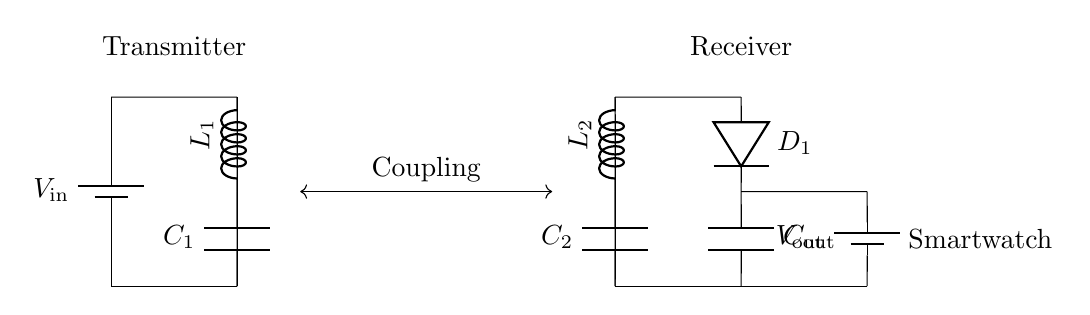What is the input voltage in the circuit? The input voltage is labeled as V_in on the transmitter side of the circuit, indicating the source voltage supplied to the circuit.
Answer: V_in What components are used in the transmitter? The transmitter consists of a battery, an inductor labeled L1, and a capacitor labeled C1. These components are connected to form the charging mechanism.
Answer: Battery, L1, C1 What type of diode is present in the receiver? The diode in the receiver is labeled as D1, which is a standard signal diode used for rectifying the current from AC to DC in the circuit.
Answer: D1 How many capacitors are used in the circuit? There are three capacitors used in the circuit: C1 connected to the transmitter, C2 in the receiver, and C_out at the output.
Answer: Three Which components are labeled as inductors? The inductors are labeled as L1 in the transmitter and L2 in the receiver, highlighting their role in energy transfer between the two sides of the circuit.
Answer: L1, L2 What is the purpose of the coupling between the transmitter and receiver? The coupling allows for the transfer of power wirelessly from the transmitter to the receiver by establishing a magnetic field between L1 and L2, enabling energy to be transferred without a physical connection.
Answer: Power transfer What is the output voltage in the circuit? The output voltage is labeled as V_out and is found at the output component of the receiver side, indicating the voltage supplied to the connected device, which is the smartwatch in this case.
Answer: V_out 